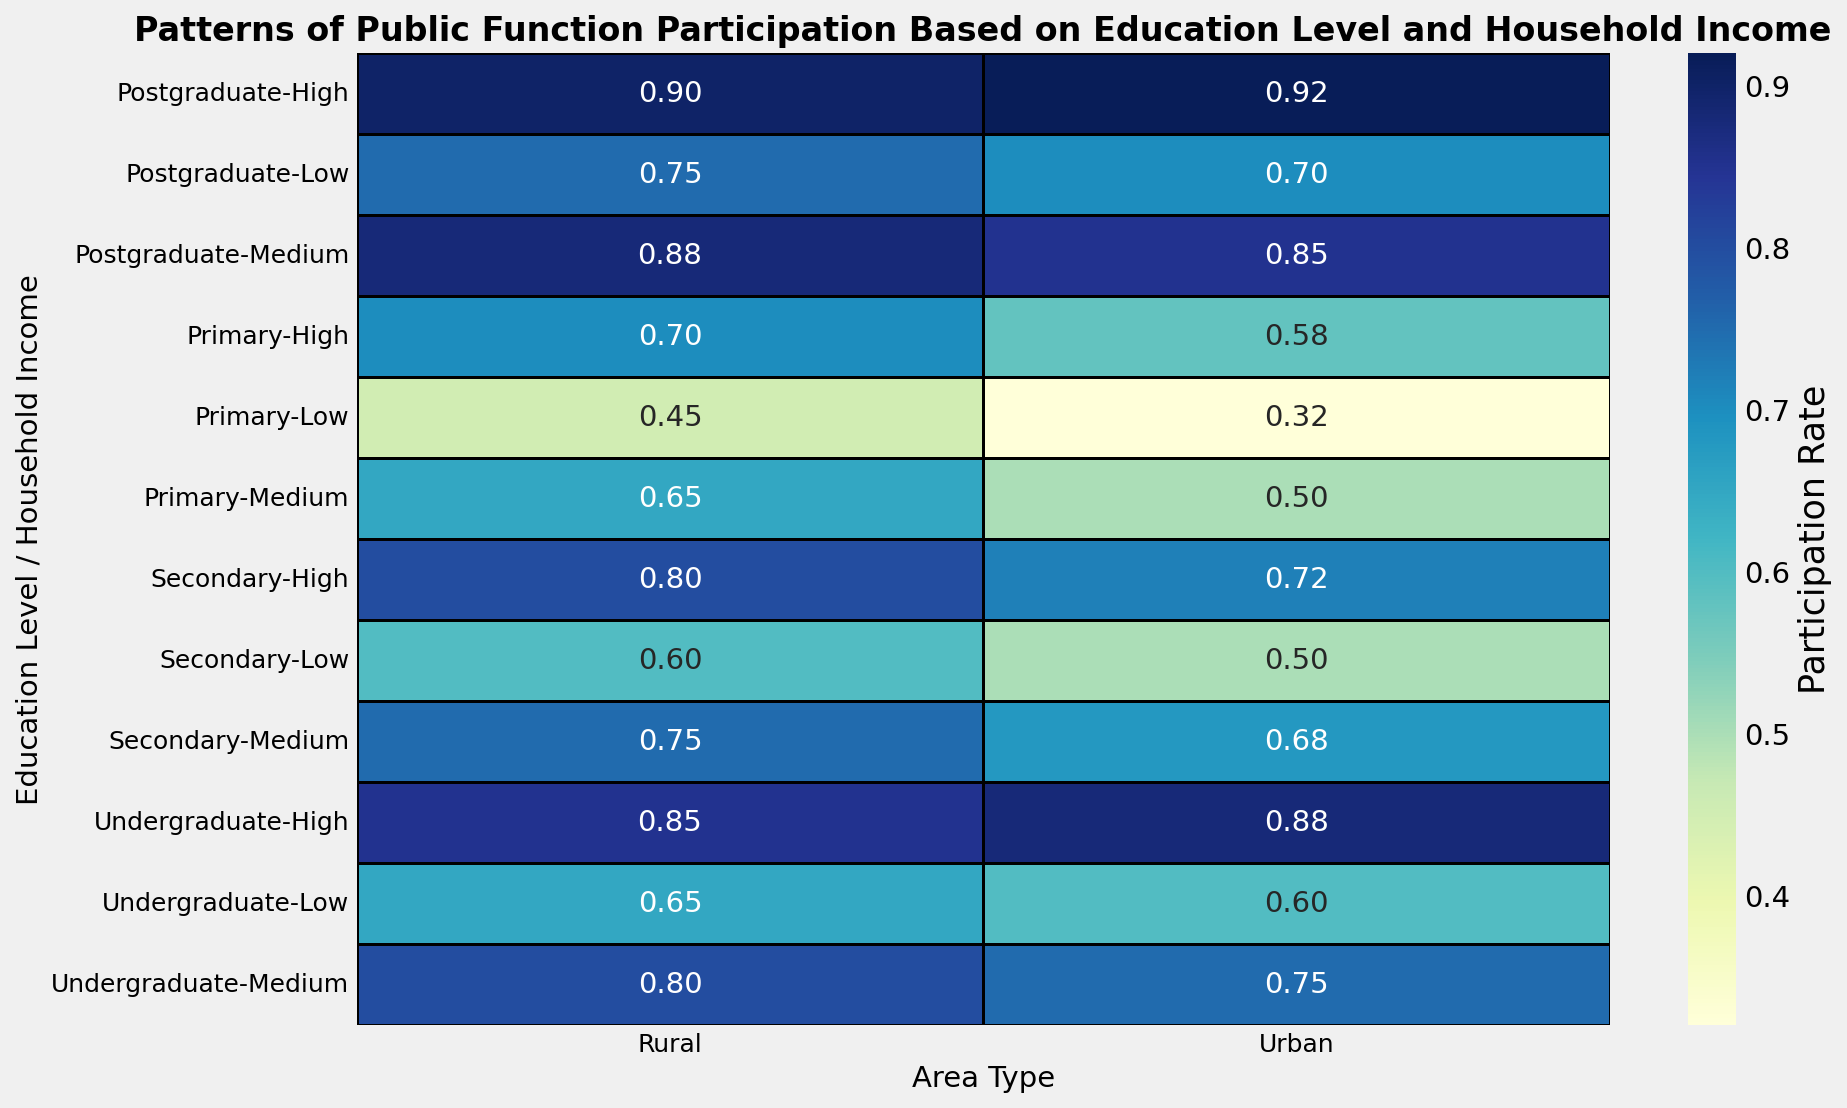What's the participation rate for undergraduates with high household income in urban areas? First, locate the 'Undergraduate' row. Next, look under 'High' household income and 'Urban' area. The participation rate is 0.88
Answer: 0.88 Which area type shows a higher participation rate for secondary education with medium household income? First, identify the row for 'Secondary' education with 'Medium' household income. Then, compare the participation rates for 'Urban' (0.68) and 'Rural' (0.75) areas. Rural has a higher rate
Answer: Rural What is the difference in participation rates between urban and rural areas for postgraduates with low household income? Locate the 'Postgraduate' row with 'Low' household income. The participation rates for 'Urban' is 0.70 and for 'Rural' is 0.75. Calculate the difference: 0.75 - 0.70 = 0.05
Answer: 0.05 Which group has the highest overall participation rate? Look through all rows and columns for the highest value. The highest participation rate is 0.92, found in the 'Postgraduate' row with 'High' household income in the 'Urban' area
Answer: Postgraduates with high household income in urban areas How does participation rate change with increasing household income for primary education in rural areas? Locate the 'Primary' row for 'Rural' areas and observe the participation rates for 'Low' (0.45), 'Medium' (0.65), and 'High' (0.70) household incomes. The rates increase from low to high income
Answer: It increases Which has a higher participation rate: undergraduates with low household income in urban areas or postgraduates with medium household income in rural areas? Locate 'Undergraduate' with 'Low' household income in 'Urban' (0.60) and 'Postgraduate' with 'Medium' household income in 'Rural' (0.88). The latter has a higher rate
Answer: Postgraduates with medium household income in rural areas What is the average participation rate for secondary education in urban areas regardless of household income? Locate the 'Secondary' rows for 'Urban' areas: 'Low' (0.50), 'Medium' (0.68), and 'High' (0.72). Calculate the average: (0.50 + 0.68 + 0.72)/3 = 1.90/3 = 0.63
Answer: 0.63 